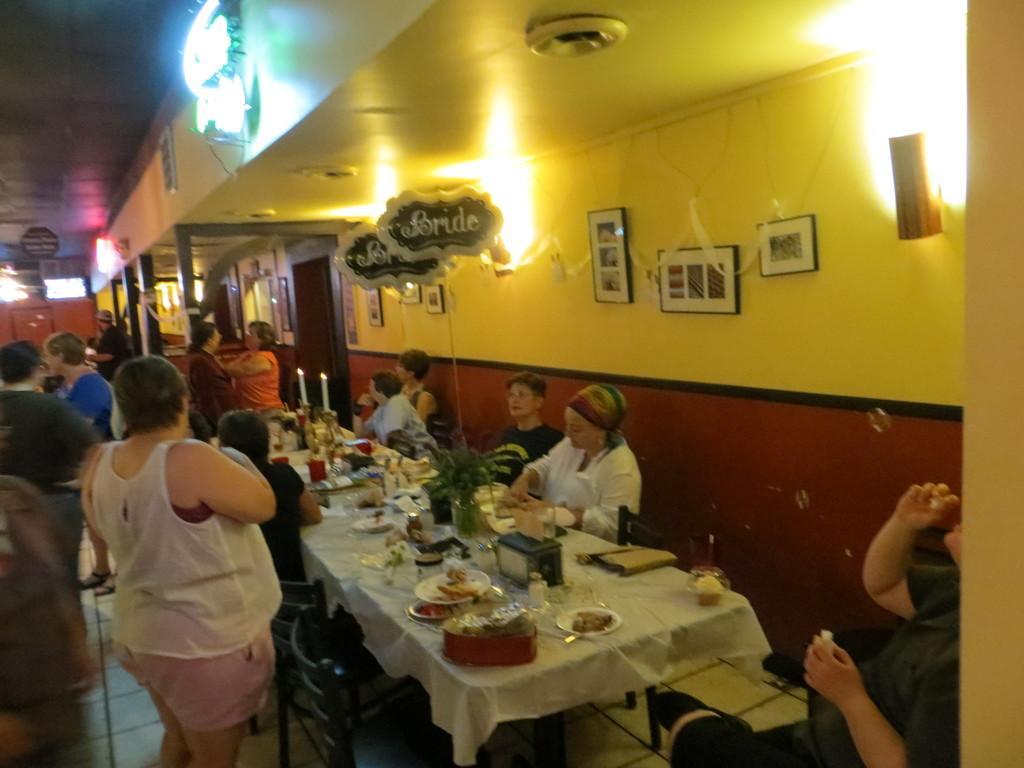How would you summarize this image in a sentence or two? This is a picture in a hotel, the people are sitting on a chair and the table is covered with a white cloth on top of the table there is a food items on the plate. This are the two candles with flame. Background of the people is a wall with red and yellow color on the wall there is a photo frames and lights. 